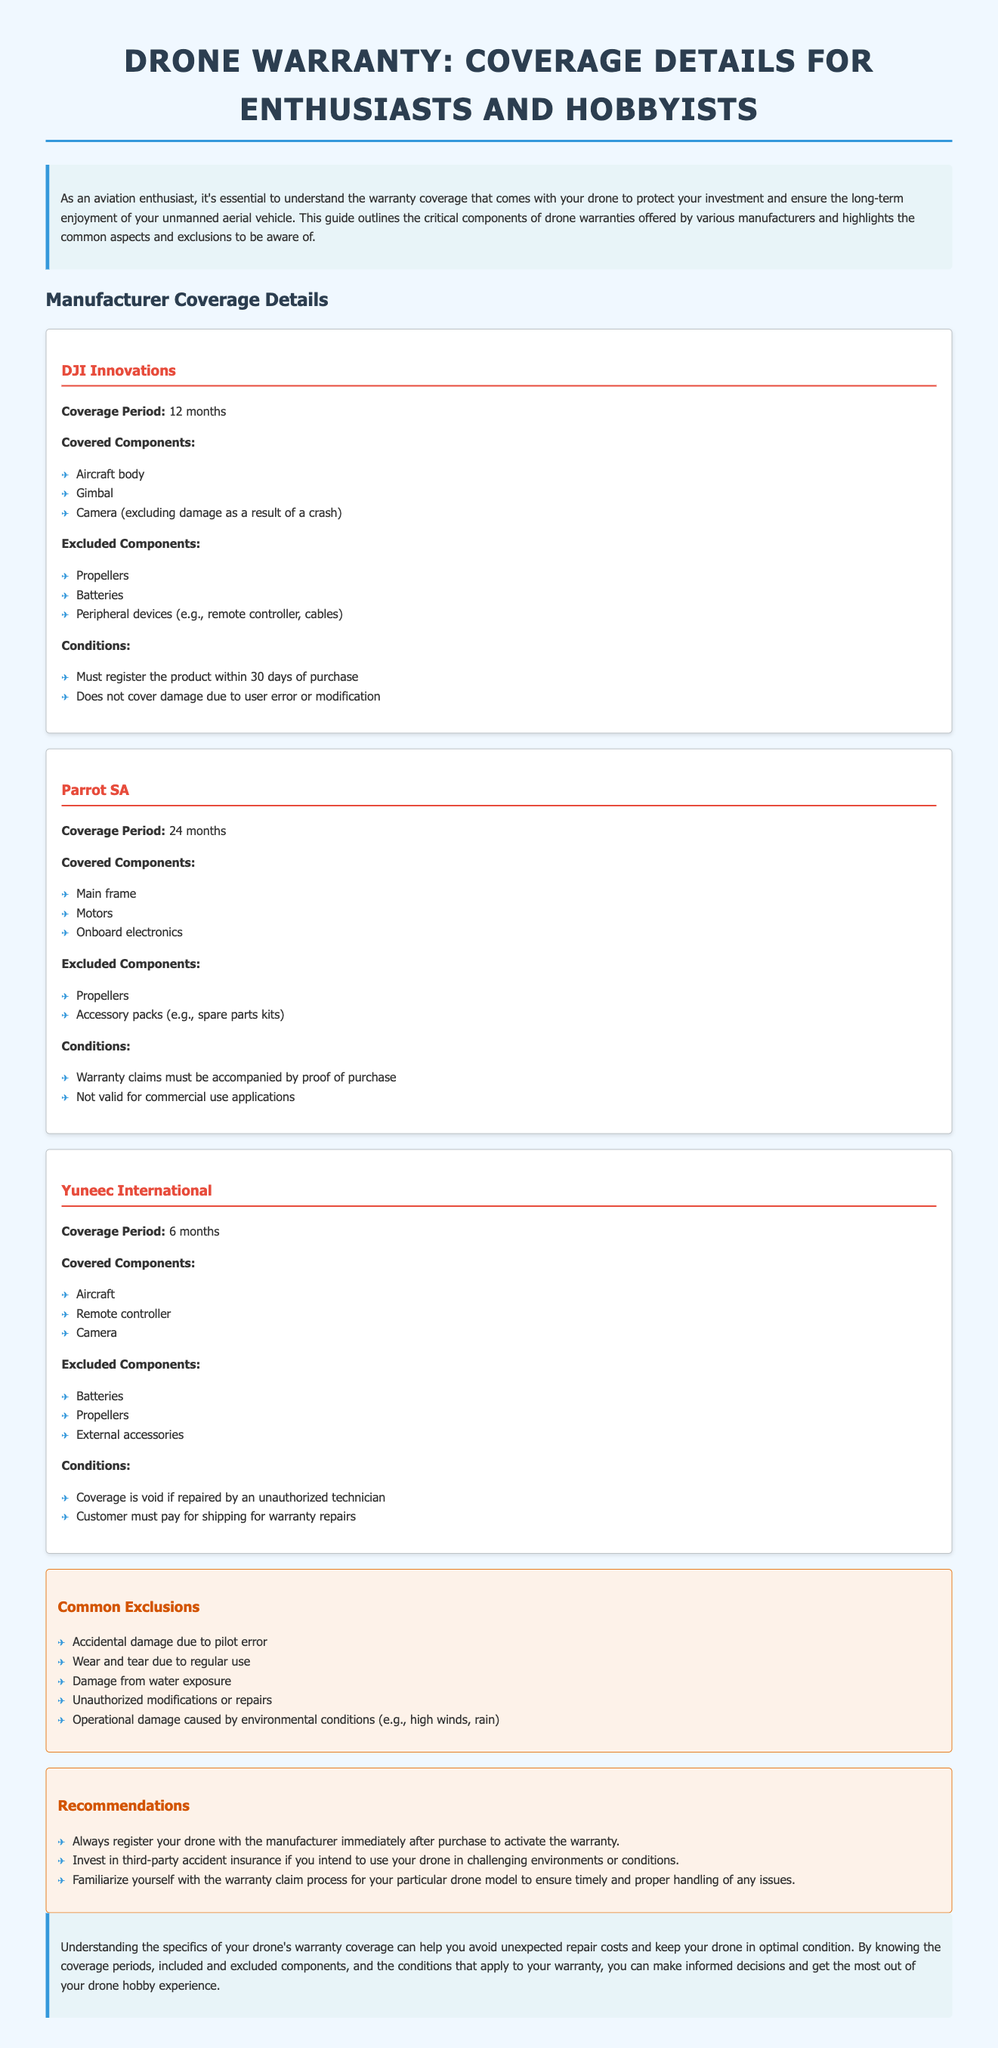What is the coverage period for DJI Innovations? The coverage period for DJI Innovations is provided in the section on manufacturer coverage details.
Answer: 12 months Which components are excluded in Parrot SA warranty? The excluded components for Parrot SA warranty are listed under the manufacturer's coverage details.
Answer: Propellers, Accessory packs What must be provided for Yuneec International warranty claims? The conditions for Yuneec International warranty claims are outlined in the document.
Answer: Proof of purchase What is the coverage period for Parrot SA? The coverage period is specified in the section dedicated to each manufacturer.
Answer: 24 months What are the common exclusions listed in the document? The common exclusions provided in the document highlight specific damages not covered by warranties.
Answer: Accidental damage due to pilot error Are batteries covered under the DJI Innovations warranty? The covered and excluded components for each manufacturer directly answer this question.
Answer: No What should you do immediately after purchasing your drone? The recommendations section provides advice on warranty activation.
Answer: Register your drone What is the coverage period for Yuneec International? The coverage period is clearly mentioned in the section discussing the manufacturer’s warranty.
Answer: 6 months 